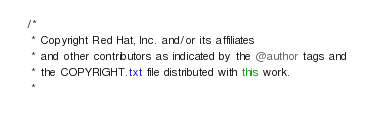Convert code to text. <code><loc_0><loc_0><loc_500><loc_500><_Java_>/*
 * Copyright Red Hat, Inc. and/or its affiliates
 * and other contributors as indicated by the @author tags and
 * the COPYRIGHT.txt file distributed with this work.
 *</code> 